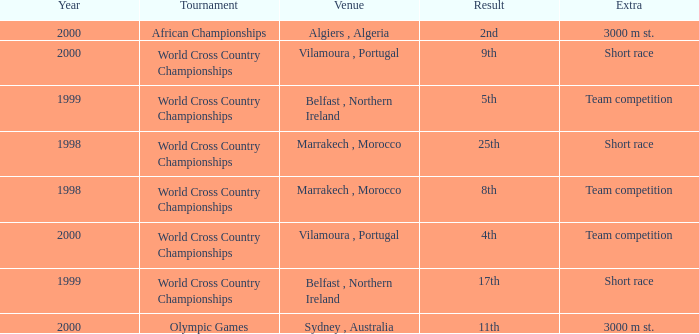Tell me the extra for tournament of olympic games 3000 m st. 